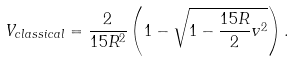<formula> <loc_0><loc_0><loc_500><loc_500>V _ { c l a s s i c a l } = \frac { 2 } { 1 5 R ^ { 2 } } \left ( 1 - \sqrt { 1 - \frac { 1 5 R } { 2 } v ^ { 2 } } \right ) .</formula> 